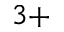<formula> <loc_0><loc_0><loc_500><loc_500>3 +</formula> 